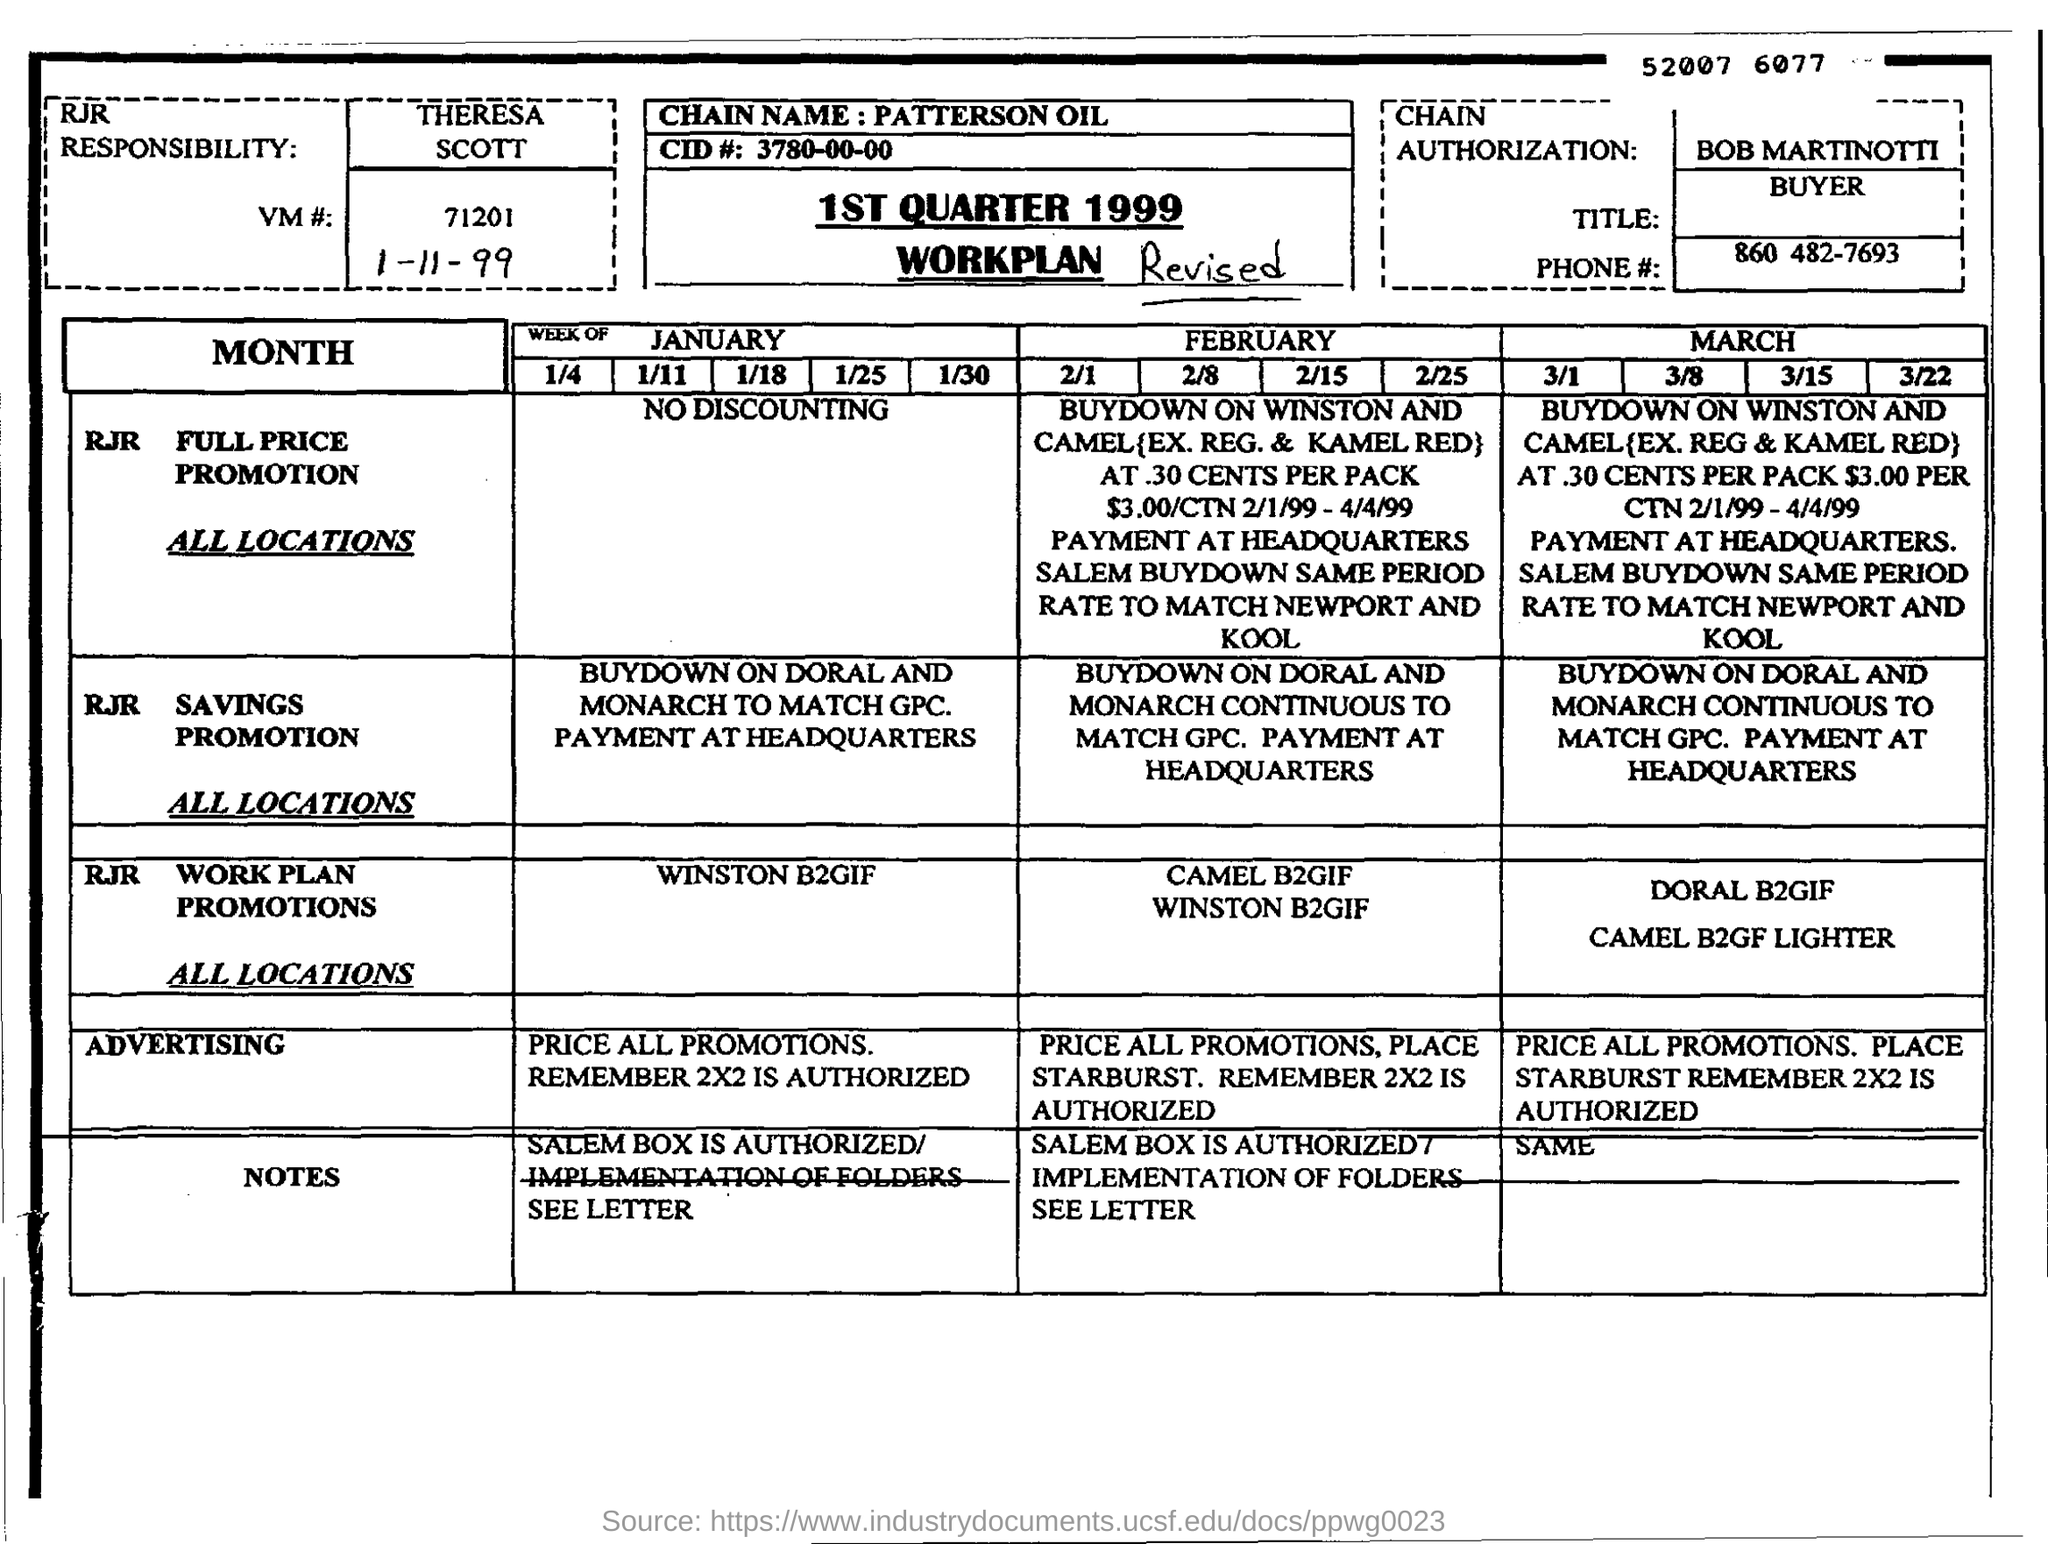Give some essential details in this illustration. The date mentioned on this page is November 1, 1999. The phone number in the document is 860 482-7693. 